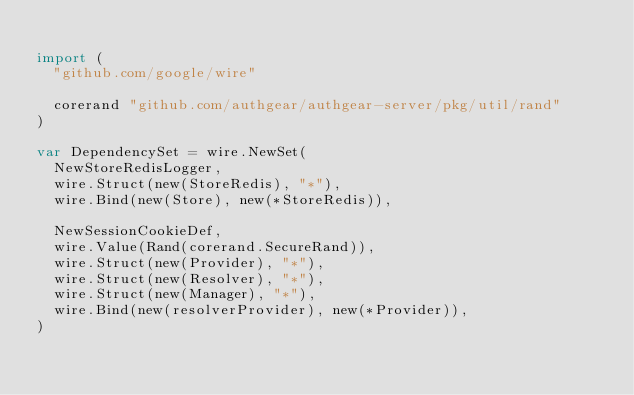<code> <loc_0><loc_0><loc_500><loc_500><_Go_>
import (
	"github.com/google/wire"

	corerand "github.com/authgear/authgear-server/pkg/util/rand"
)

var DependencySet = wire.NewSet(
	NewStoreRedisLogger,
	wire.Struct(new(StoreRedis), "*"),
	wire.Bind(new(Store), new(*StoreRedis)),

	NewSessionCookieDef,
	wire.Value(Rand(corerand.SecureRand)),
	wire.Struct(new(Provider), "*"),
	wire.Struct(new(Resolver), "*"),
	wire.Struct(new(Manager), "*"),
	wire.Bind(new(resolverProvider), new(*Provider)),
)
</code> 